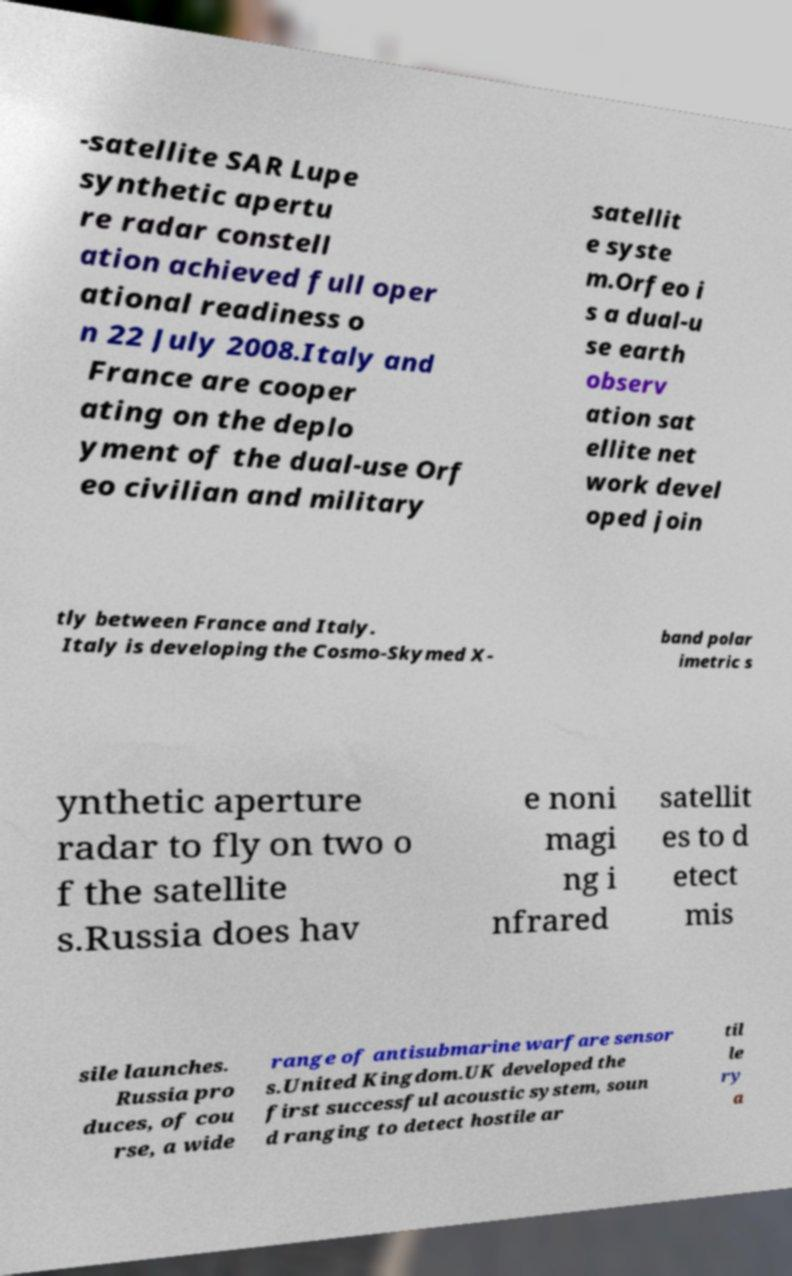I need the written content from this picture converted into text. Can you do that? -satellite SAR Lupe synthetic apertu re radar constell ation achieved full oper ational readiness o n 22 July 2008.Italy and France are cooper ating on the deplo yment of the dual-use Orf eo civilian and military satellit e syste m.Orfeo i s a dual-u se earth observ ation sat ellite net work devel oped join tly between France and Italy. Italy is developing the Cosmo-Skymed X- band polar imetric s ynthetic aperture radar to fly on two o f the satellite s.Russia does hav e noni magi ng i nfrared satellit es to d etect mis sile launches. Russia pro duces, of cou rse, a wide range of antisubmarine warfare sensor s.United Kingdom.UK developed the first successful acoustic system, soun d ranging to detect hostile ar til le ry a 